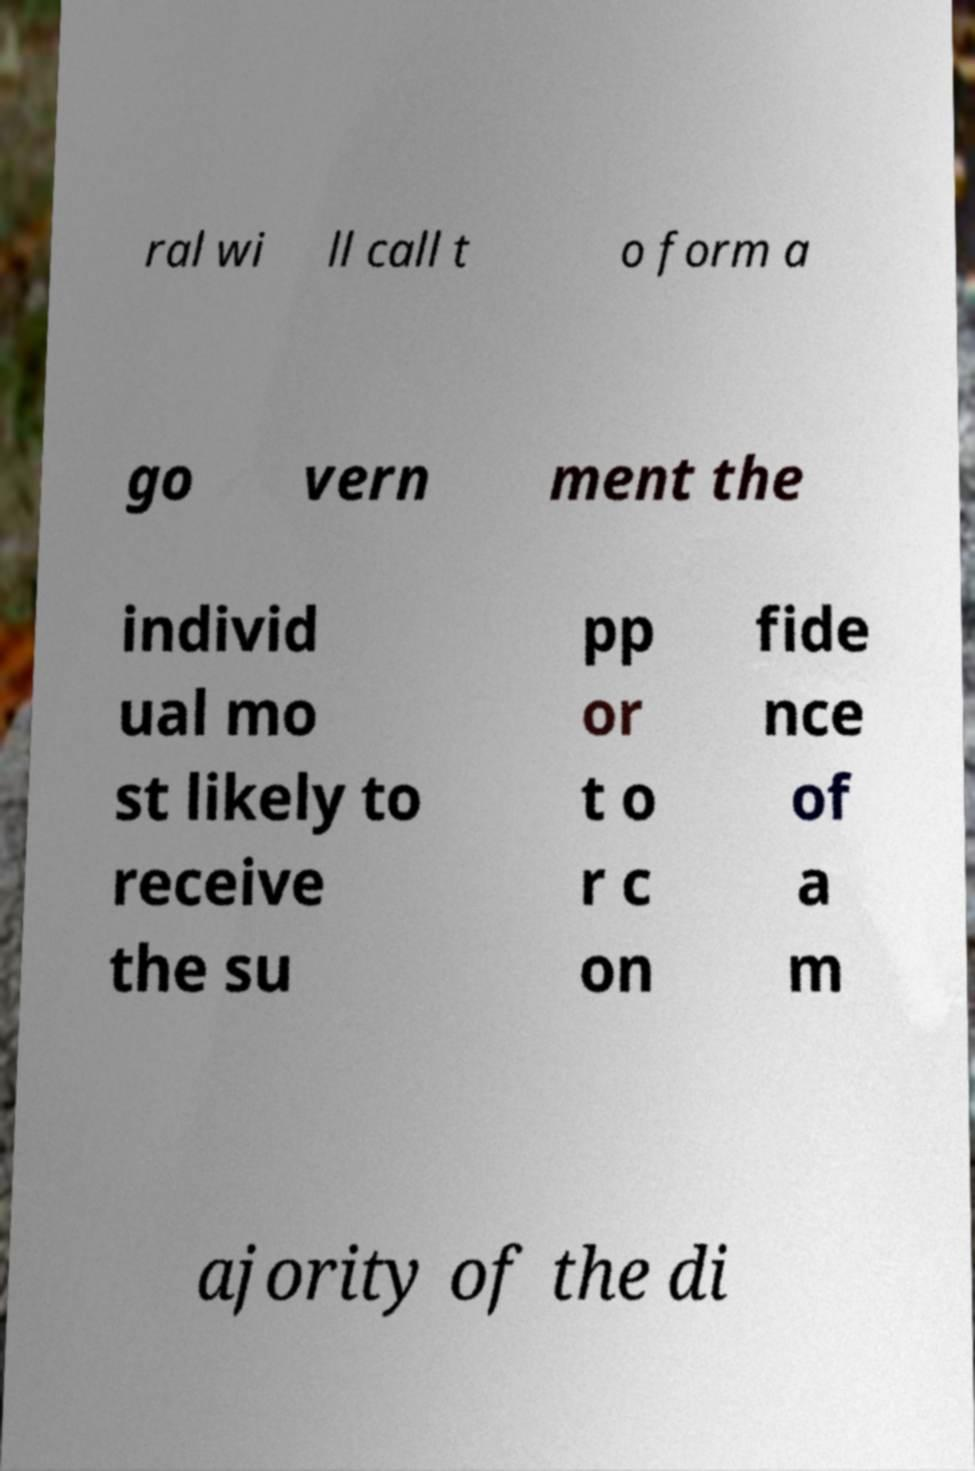Can you read and provide the text displayed in the image?This photo seems to have some interesting text. Can you extract and type it out for me? ral wi ll call t o form a go vern ment the individ ual mo st likely to receive the su pp or t o r c on fide nce of a m ajority of the di 